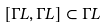Convert formula to latex. <formula><loc_0><loc_0><loc_500><loc_500>[ \Gamma L , \Gamma L ] \subset \Gamma L</formula> 